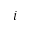<formula> <loc_0><loc_0><loc_500><loc_500>i</formula> 